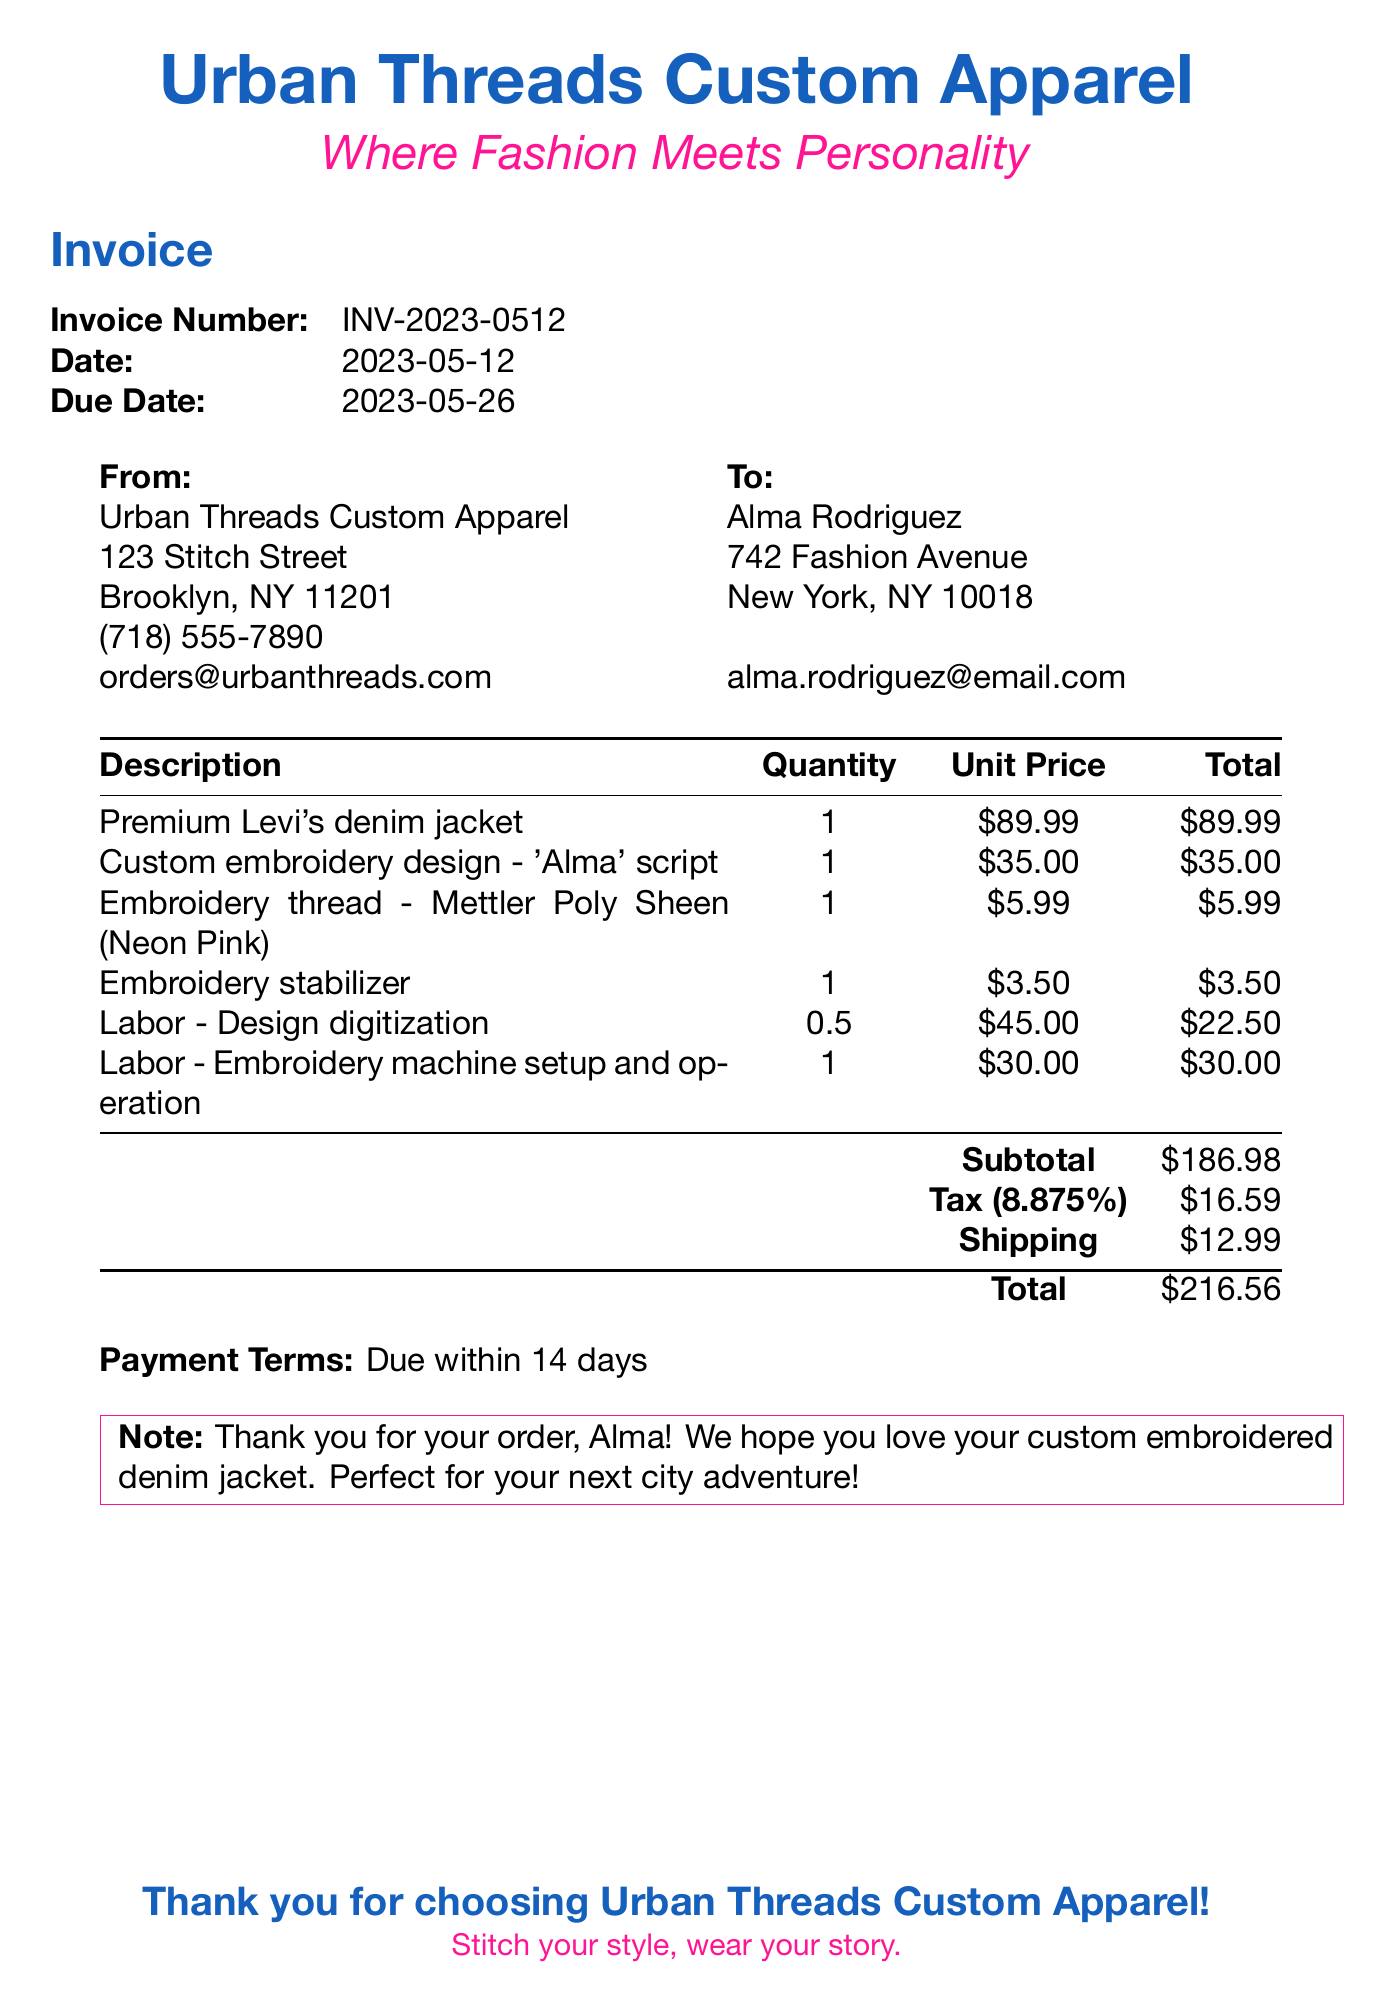What is the invoice number? The invoice number is listed at the top of the document for reference.
Answer: INV-2023-0512 What is the due date for this invoice? The due date is specified to indicate when payment is expected.
Answer: 2023-05-26 Who is the vendor for the custom jacket? The vendor information is provided to give credit for the service.
Answer: Urban Threads Custom Apparel What item has the highest unit price? The unit prices of all items can be compared to find the highest one.
Answer: Premium Levi's denim jacket What is the subtotal of the items? The subtotal indicates the total cost before tax and shipping.
Answer: $186.98 What is the shipping cost? The shipping cost is clearly stated in the document.
Answer: $12.99 What is the tax rate applied to the invoice? The tax rate is provided to show how much tax is charged.
Answer: 8.875% What is the total amount due for the invoice? The total includes the subtotal, tax, and shipping.
Answer: $216.56 What is the payment term mentioned? The payment term indicates when the invoice should be paid.
Answer: Due within 14 days 